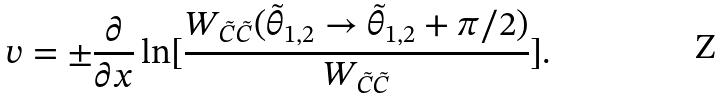Convert formula to latex. <formula><loc_0><loc_0><loc_500><loc_500>v = \pm \frac { \partial } { \partial x } \ln [ \frac { W _ { \tilde { C } \tilde { C } } ( \tilde { \theta } _ { 1 , 2 } \rightarrow \tilde { \theta } _ { 1 , 2 } + \pi / 2 ) } { W _ { \tilde { C } \tilde { C } } } ] .</formula> 